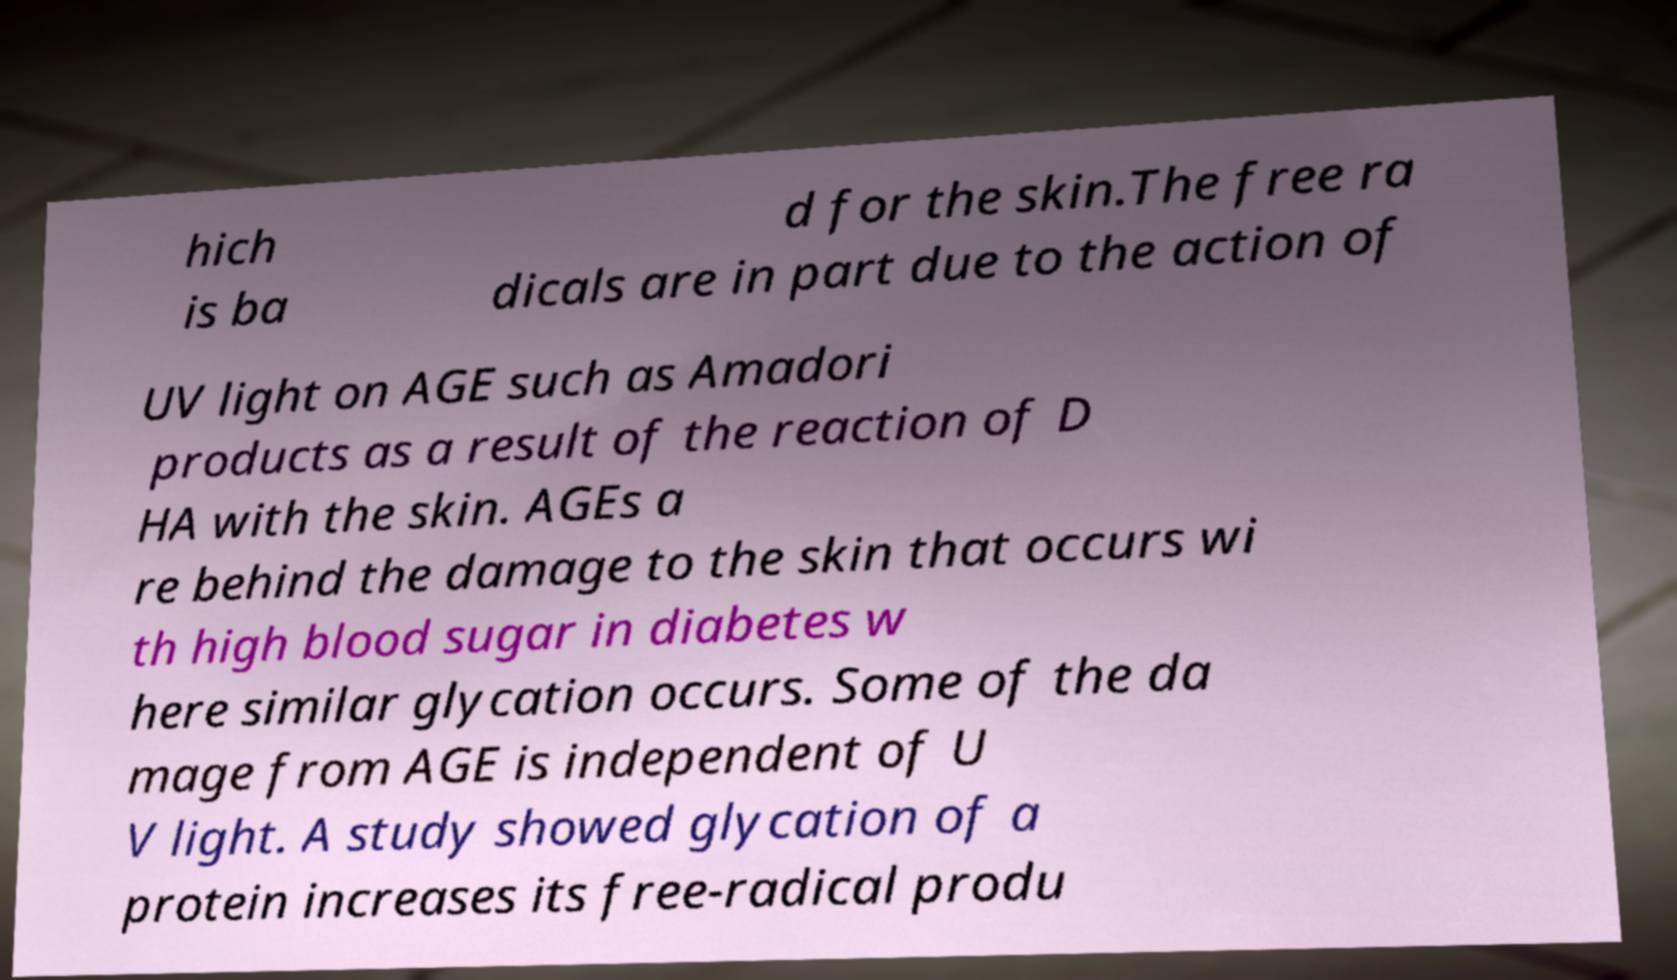Could you extract and type out the text from this image? hich is ba d for the skin.The free ra dicals are in part due to the action of UV light on AGE such as Amadori products as a result of the reaction of D HA with the skin. AGEs a re behind the damage to the skin that occurs wi th high blood sugar in diabetes w here similar glycation occurs. Some of the da mage from AGE is independent of U V light. A study showed glycation of a protein increases its free-radical produ 